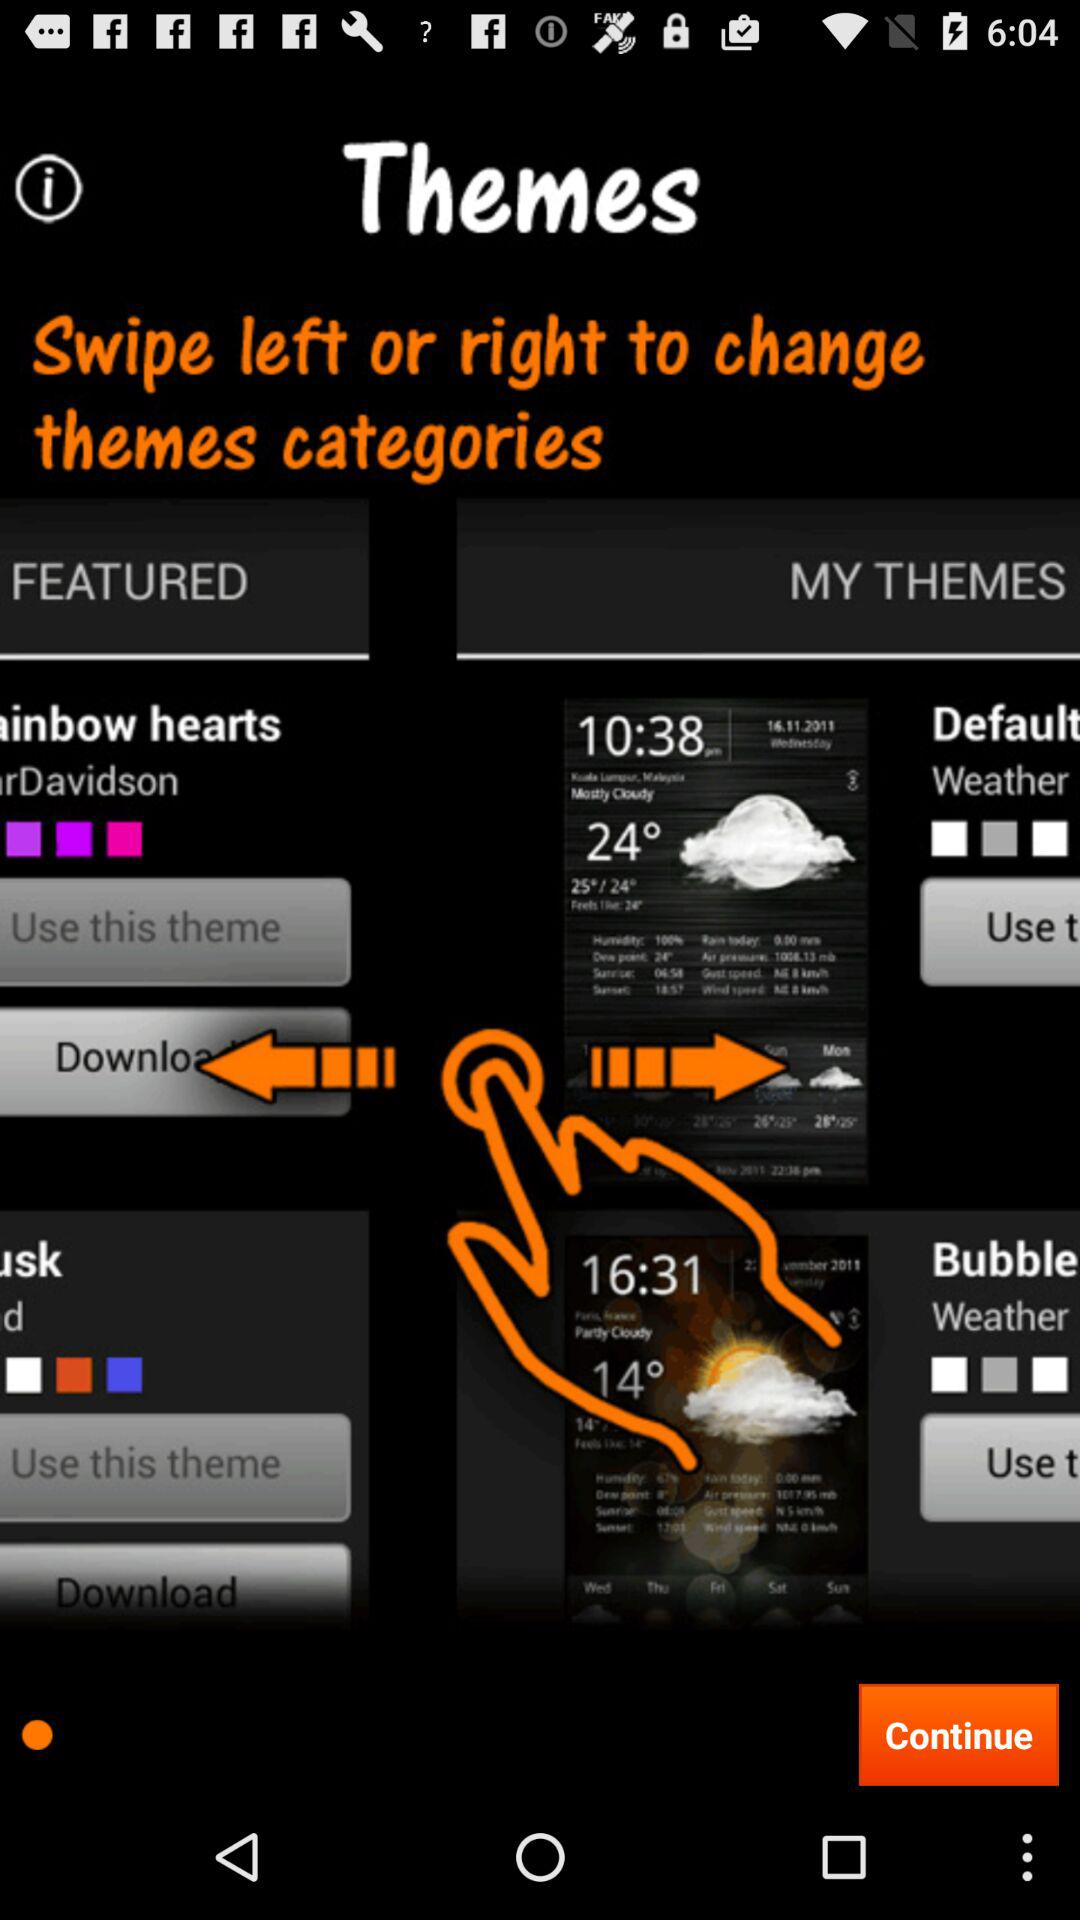How to change the theme categories? To change the theme categories, swipe left or right. 